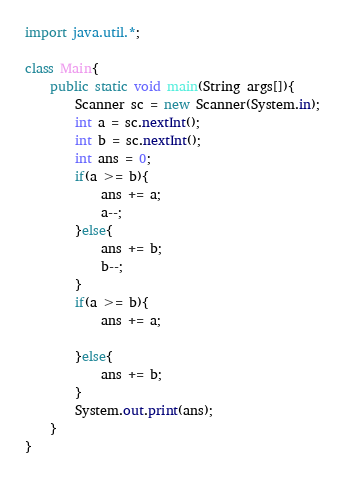Convert code to text. <code><loc_0><loc_0><loc_500><loc_500><_Java_>import java.util.*;

class Main{
	public static void main(String args[]){
		Scanner sc = new Scanner(System.in);
		int a = sc.nextInt();
		int b = sc.nextInt();
		int ans = 0;
		if(a >= b){
			ans += a;
			a--;
		}else{
			ans += b;
			b--;
		}
		if(a >= b){
			ans += a;

		}else{
			ans += b;
		}
		System.out.print(ans);
	}
}
</code> 